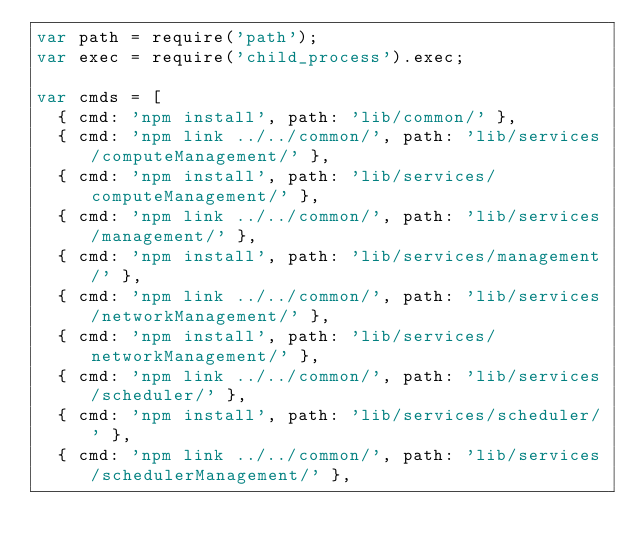Convert code to text. <code><loc_0><loc_0><loc_500><loc_500><_JavaScript_>var path = require('path');
var exec = require('child_process').exec;

var cmds = [
  { cmd: 'npm install', path: 'lib/common/' },
  { cmd: 'npm link ../../common/', path: 'lib/services/computeManagement/' },
  { cmd: 'npm install', path: 'lib/services/computeManagement/' },
  { cmd: 'npm link ../../common/', path: 'lib/services/management/' },
  { cmd: 'npm install', path: 'lib/services/management/' },
  { cmd: 'npm link ../../common/', path: 'lib/services/networkManagement/' },
  { cmd: 'npm install', path: 'lib/services/networkManagement/' },
  { cmd: 'npm link ../../common/', path: 'lib/services/scheduler/' },
  { cmd: 'npm install', path: 'lib/services/scheduler/' },
  { cmd: 'npm link ../../common/', path: 'lib/services/schedulerManagement/' },</code> 